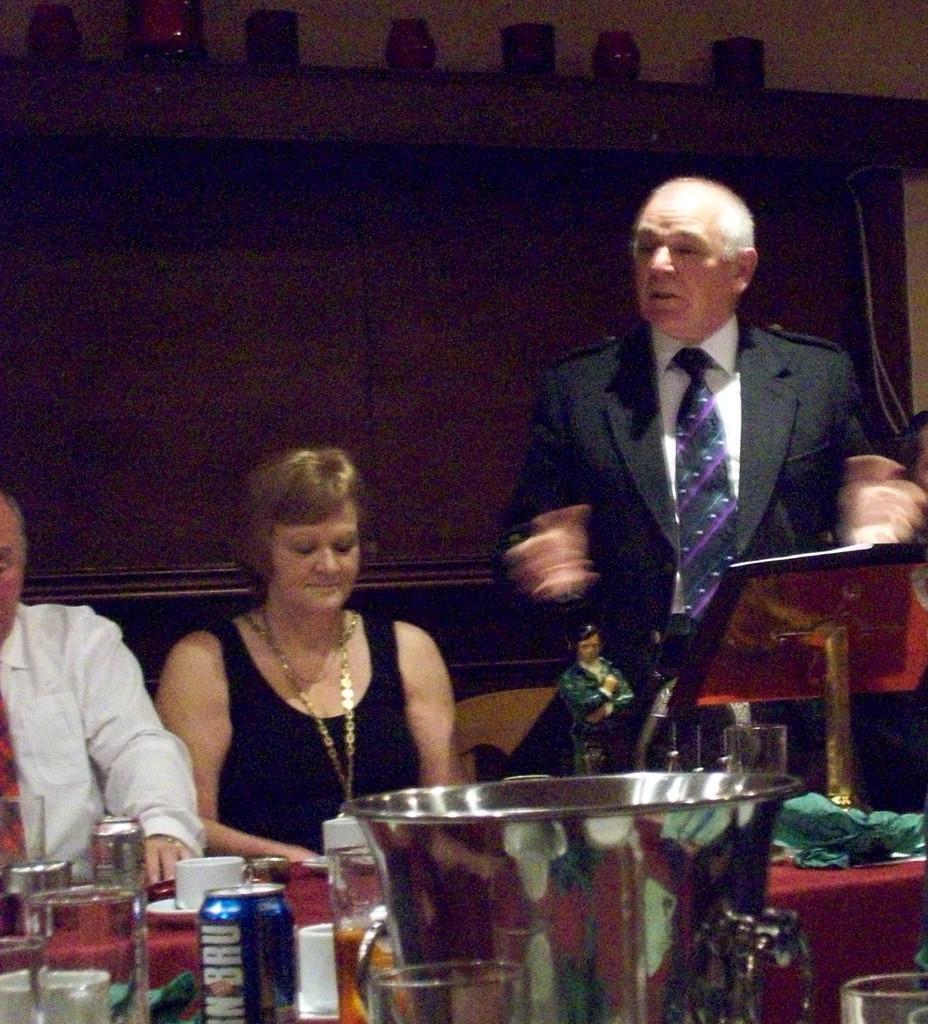How would you summarize this image in a sentence or two? In this image there is a table at the bottom. On the table there are glasses,cups,buckets,soft drink tins on it. In front of the table there are two persons sitting in the chairs. On the right side there is a person standing by wearing the suit and tie. In front of him there is a table. 